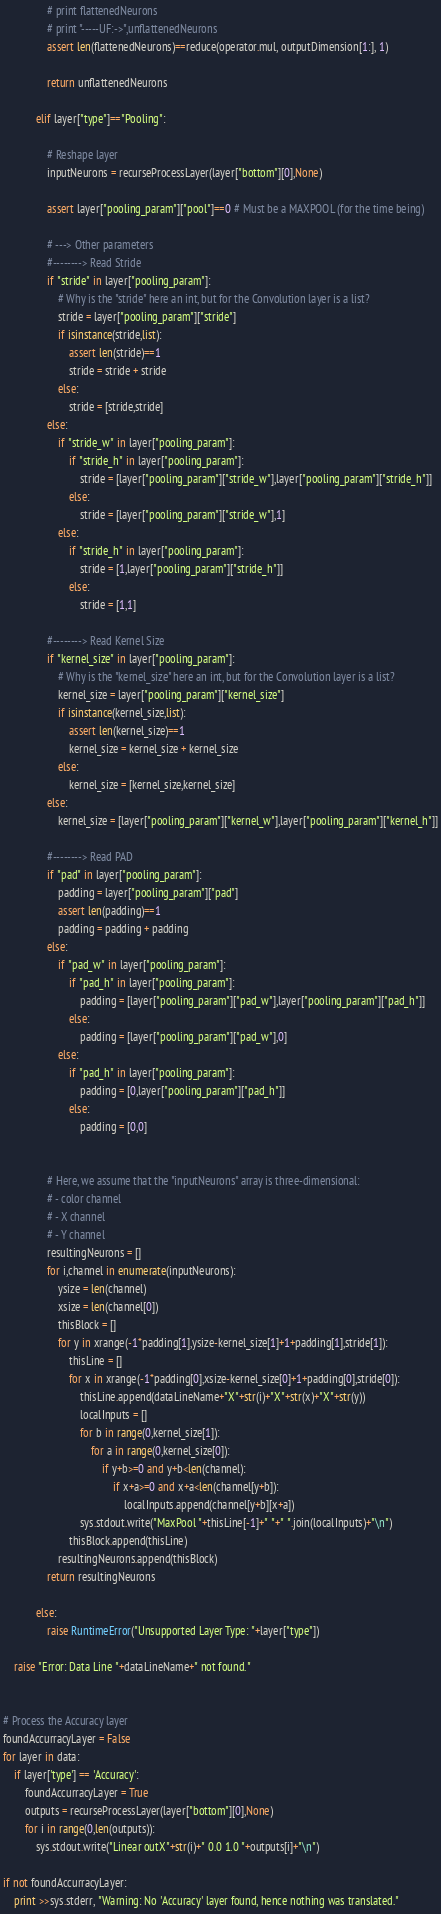<code> <loc_0><loc_0><loc_500><loc_500><_Python_>                # print flattenedNeurons
                # print "-----UF:->",unflattenedNeurons
                assert len(flattenedNeurons)==reduce(operator.mul, outputDimension[1:], 1)
                              
                return unflattenedNeurons

            elif layer["type"]=="Pooling":
            
                # Reshape layer
                inputNeurons = recurseProcessLayer(layer["bottom"][0],None)
                
                assert layer["pooling_param"]["pool"]==0 # Must be a MAXPOOL (for the time being)
                
                # ---> Other parameters
                #--------> Read Stride
                if "stride" in layer["pooling_param"]:
                    # Why is the "stride" here an int, but for the Convolution layer is a list?
                    stride = layer["pooling_param"]["stride"]
                    if isinstance(stride,list):
                        assert len(stride)==1
                        stride = stride + stride
                    else:
                        stride = [stride,stride]
                else:
                    if "stride_w" in layer["pooling_param"]:
                        if "stride_h" in layer["pooling_param"]:
                            stride = [layer["pooling_param"]["stride_w"],layer["pooling_param"]["stride_h"]]
                        else:
                            stride = [layer["pooling_param"]["stride_w"],1]
                    else:
                        if "stride_h" in layer["pooling_param"]:
                            stride = [1,layer["pooling_param"]["stride_h"]]
                        else:
                            stride = [1,1]
                
                #--------> Read Kernel Size
                if "kernel_size" in layer["pooling_param"]:
                    # Why is the "kernel_size" here an int, but for the Convolution layer is a list?
                    kernel_size = layer["pooling_param"]["kernel_size"]
                    if isinstance(kernel_size,list):
                        assert len(kernel_size)==1
                        kernel_size = kernel_size + kernel_size
                    else:
                        kernel_size = [kernel_size,kernel_size]
                else:
                    kernel_size = [layer["pooling_param"]["kernel_w"],layer["pooling_param"]["kernel_h"]]

                #--------> Read PAD
                if "pad" in layer["pooling_param"]:
                    padding = layer["pooling_param"]["pad"]
                    assert len(padding)==1
                    padding = padding + padding
                else:
                    if "pad_w" in layer["pooling_param"]:
                        if "pad_h" in layer["pooling_param"]:
                            padding = [layer["pooling_param"]["pad_w"],layer["pooling_param"]["pad_h"]]
                        else:
                            padding = [layer["pooling_param"]["pad_w"],0]
                    else:
                        if "pad_h" in layer["pooling_param"]:
                            padding = [0,layer["pooling_param"]["pad_h"]]
                        else:
                            padding = [0,0]

                
                # Here, we assume that the "inputNeurons" array is three-dimensional:
                # - color channel
                # - X channel
                # - Y channel
                resultingNeurons = []
                for i,channel in enumerate(inputNeurons):
                    ysize = len(channel)
                    xsize = len(channel[0])
                    thisBlock = []
                    for y in xrange(-1*padding[1],ysize-kernel_size[1]+1+padding[1],stride[1]):
                        thisLine = []                    
                        for x in xrange(-1*padding[0],xsize-kernel_size[0]+1+padding[0],stride[0]):
                            thisLine.append(dataLineName+"X"+str(i)+"X"+str(x)+"X"+str(y))
                            localInputs = []
                            for b in range(0,kernel_size[1]):
                                for a in range(0,kernel_size[0]):
                                    if y+b>=0 and y+b<len(channel):
                                        if x+a>=0 and x+a<len(channel[y+b]):
                                            localInputs.append(channel[y+b][x+a]) 
                            sys.stdout.write("MaxPool "+thisLine[-1]+" "+" ".join(localInputs)+"\n")
                        thisBlock.append(thisLine)
                    resultingNeurons.append(thisBlock)
                return resultingNeurons                    
                    
            else:
                raise RuntimeError("Unsupported Layer Type: "+layer["type"])
            
    raise "Error: Data Line "+dataLineName+" not found."


# Process the Accuracy layer
foundAccurracyLayer = False
for layer in data:
    if layer['type'] == 'Accuracy':
        foundAccurracyLayer = True
        outputs = recurseProcessLayer(layer["bottom"][0],None)
        for i in range(0,len(outputs)):
            sys.stdout.write("Linear outX"+str(i)+" 0.0 1.0 "+outputs[i]+"\n")
                
if not foundAccurracyLayer:
    print >>sys.stderr, "Warning: No 'Accuracy' layer found, hence nothing was translated."
</code> 